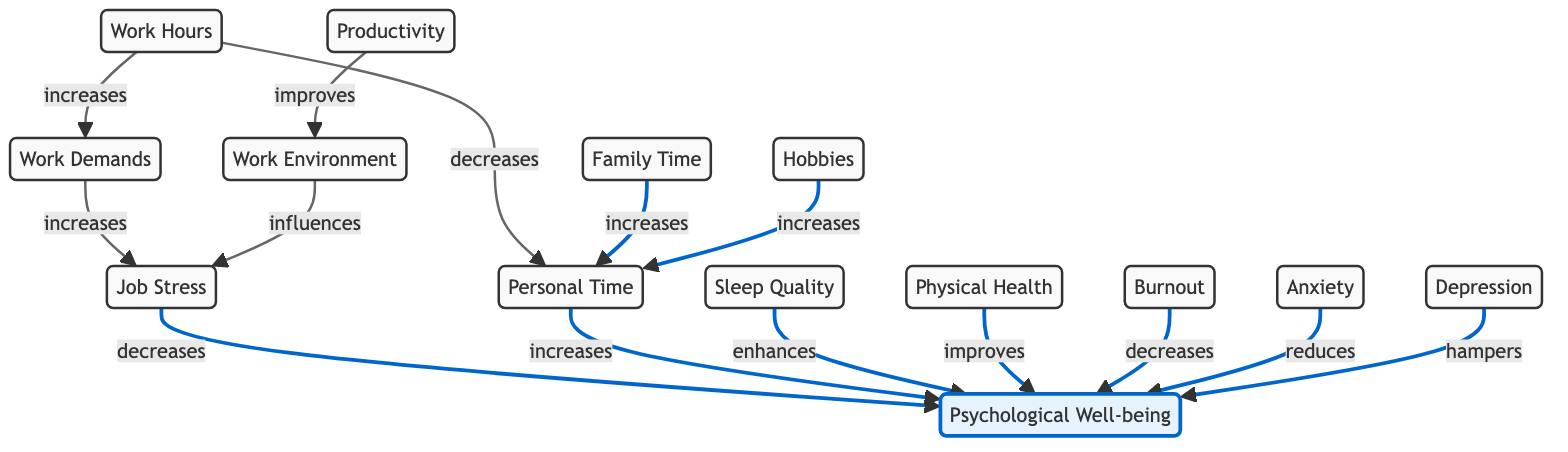What do work demands increase? The diagram shows a direct link from "Work Demands" to "Job Stress" with the label "increases." Therefore, work demands have a positive effect on job stress.
Answer: Job Stress How does personal time affect psychological well-being? The diagram indicates an arrow going from "Personal Time" to "Psychological Well-being" labeled "increases." This means that an increase in personal time leads to an improvement in psychological well-being.
Answer: Increases What node is influenced by work environment? According to the diagram, "Work Environment" has a direct influence on "Job Stress," as indicated by the arrow labeled "influences." Hence, work environment affects job stress.
Answer: Job Stress What are the two factors that increase personal time? The diagram illustrates that both "Family Time" and "Hobbies" increase "Personal Time." Each has its own connection leading into personal time with the label "increases."
Answer: Family Time, Hobbies What effect does burnout have on psychological well-being? The diagram shows that "Burnout" decreases "Psychological Well-being," as the arrow is labeled "decreases," indicating a negative relationship.
Answer: Decreases How many nodes are connected to psychological well-being? By reviewing the connections in the diagram, psychological well-being has arrows coming from nine different nodes: Job Stress, Personal Time, Sleep Quality, Physical Health, Burnout, Anxiety, Depression, and indirectly related through Work Environment. Counting them gives a total of eight, as burnout has been described, but it's not directly connecting.
Answer: Eight What does an increase in work hours do to personal time? The diagram specifies an arrow from "Work Hours" to "Personal Time" with the label "decreases," indicating that longer work hours result in less personal time.
Answer: Decreases What is the relationship between anxiety and psychological well-being? The diagram outlines a direct connection where "Anxiety" reduces "Psychological Well-being," indicated by the label "reduces." Therefore, anxiety has a negative effect on mental health.
Answer: Reduces Which factors improve psychological well-being? The diagram indicates several factors that have a positive impact on psychological well-being, specifically "Sleep Quality" (enhances), "Physical Health" (improves), and "Personal Time" (increases). Therefore, these factors contribute to improved mental health.
Answer: Sleep Quality, Physical Health, Personal Time 